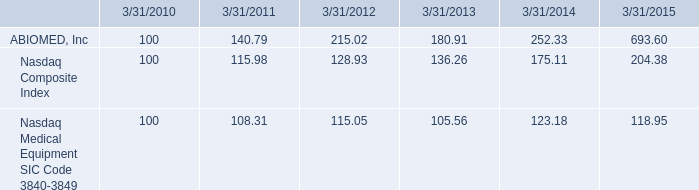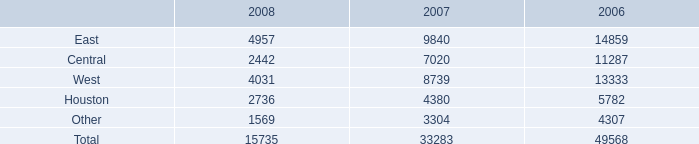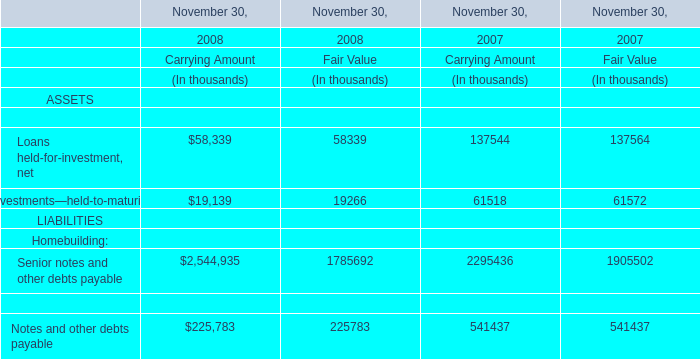what is the roi of an investment in abiomed inc from march 2010 to march 2013? 
Computations: ((180.91 - 100) / 100)
Answer: 0.8091. 